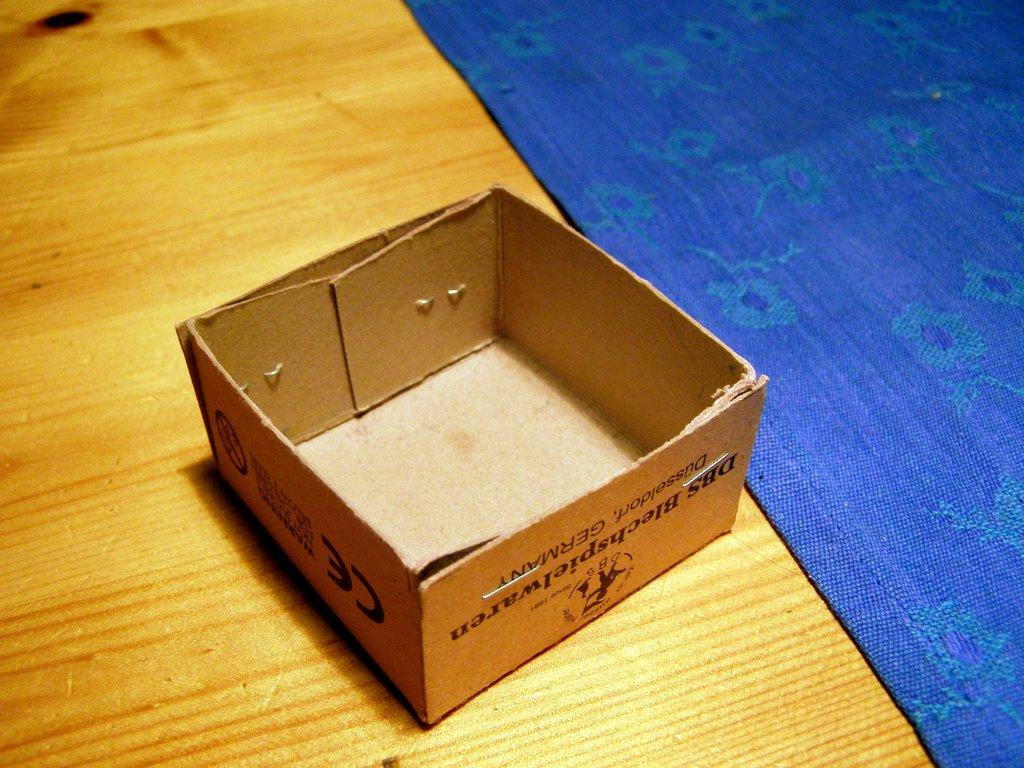Provide a one-sentence caption for the provided image. A small box from DBS Blechshpielware, Dusseldorf Germany is empty and upside down on a wooden surface. 